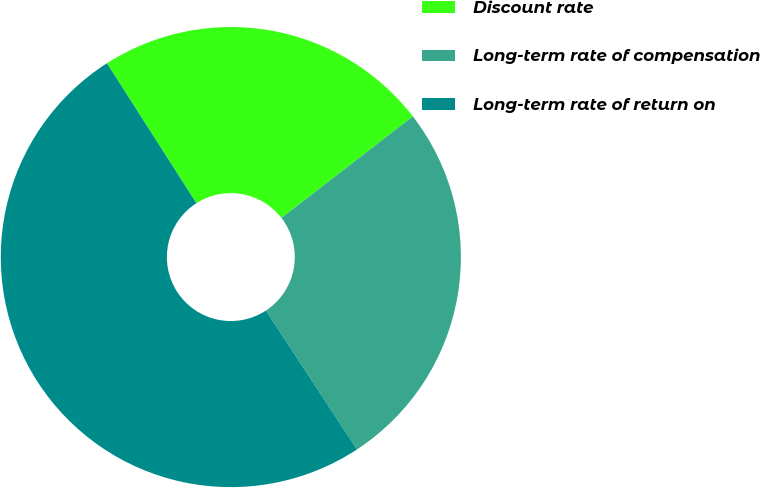Convert chart to OTSL. <chart><loc_0><loc_0><loc_500><loc_500><pie_chart><fcel>Discount rate<fcel>Long-term rate of compensation<fcel>Long-term rate of return on<nl><fcel>23.58%<fcel>26.24%<fcel>50.18%<nl></chart> 